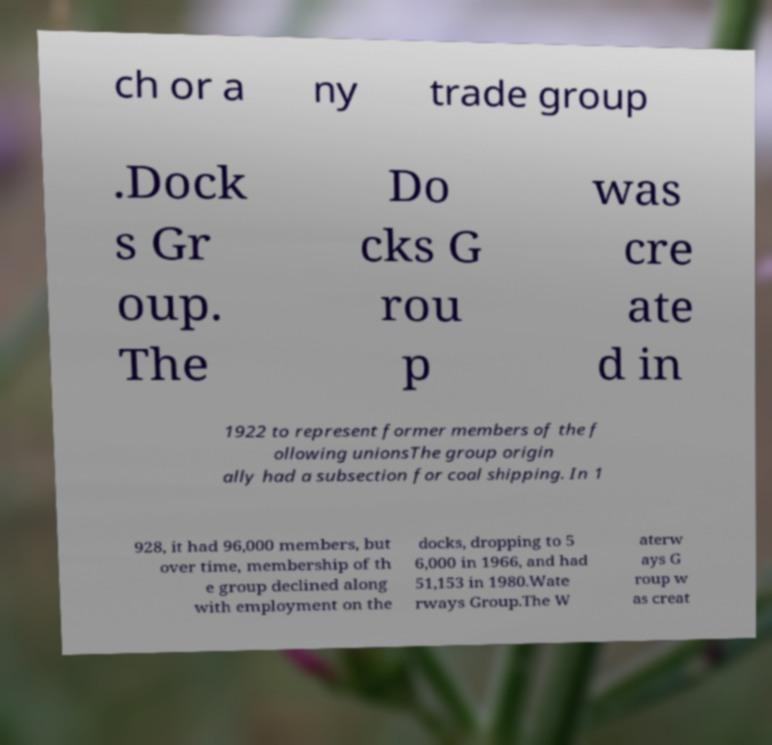Please identify and transcribe the text found in this image. ch or a ny trade group .Dock s Gr oup. The Do cks G rou p was cre ate d in 1922 to represent former members of the f ollowing unionsThe group origin ally had a subsection for coal shipping. In 1 928, it had 96,000 members, but over time, membership of th e group declined along with employment on the docks, dropping to 5 6,000 in 1966, and had 51,153 in 1980.Wate rways Group.The W aterw ays G roup w as creat 